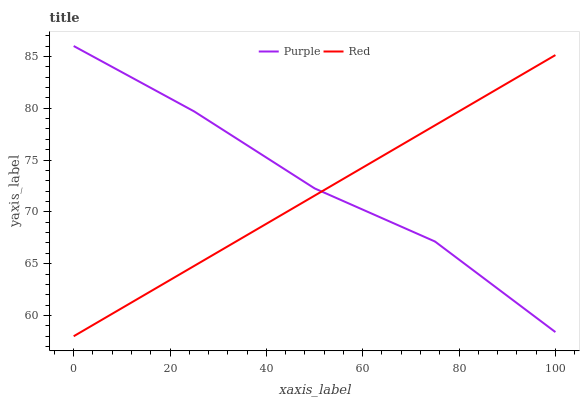Does Red have the minimum area under the curve?
Answer yes or no. Yes. Does Purple have the maximum area under the curve?
Answer yes or no. Yes. Does Red have the maximum area under the curve?
Answer yes or no. No. Is Red the smoothest?
Answer yes or no. Yes. Is Purple the roughest?
Answer yes or no. Yes. Is Red the roughest?
Answer yes or no. No. Does Red have the lowest value?
Answer yes or no. Yes. Does Purple have the highest value?
Answer yes or no. Yes. Does Red have the highest value?
Answer yes or no. No. Does Purple intersect Red?
Answer yes or no. Yes. Is Purple less than Red?
Answer yes or no. No. Is Purple greater than Red?
Answer yes or no. No. 